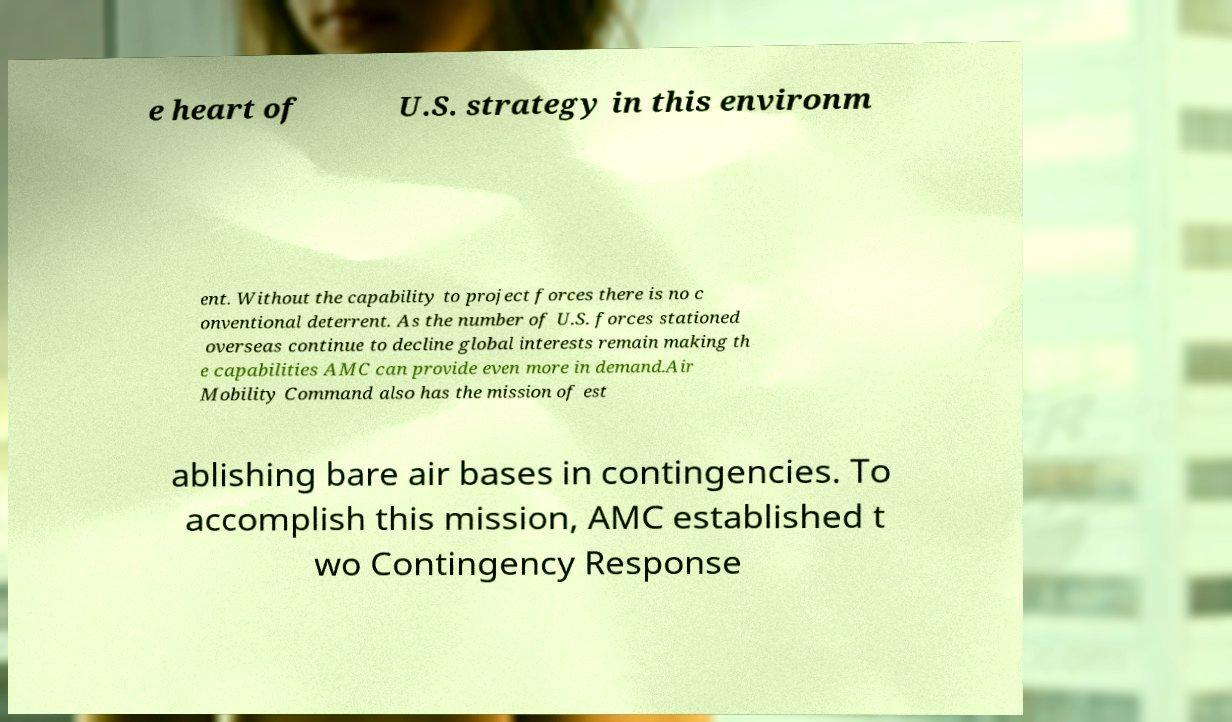What messages or text are displayed in this image? I need them in a readable, typed format. e heart of U.S. strategy in this environm ent. Without the capability to project forces there is no c onventional deterrent. As the number of U.S. forces stationed overseas continue to decline global interests remain making th e capabilities AMC can provide even more in demand.Air Mobility Command also has the mission of est ablishing bare air bases in contingencies. To accomplish this mission, AMC established t wo Contingency Response 